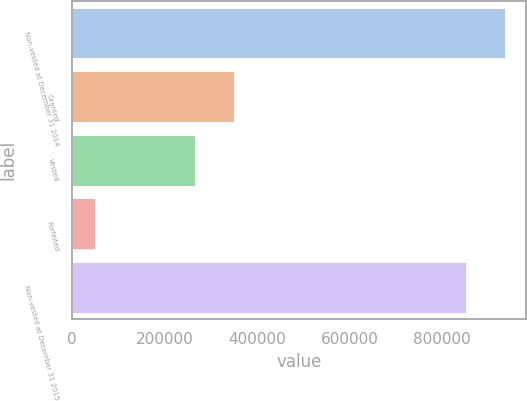Convert chart to OTSL. <chart><loc_0><loc_0><loc_500><loc_500><bar_chart><fcel>Non-vested at December 31 2014<fcel>Granted<fcel>Vested<fcel>Forfeited<fcel>Non-vested at December 31 2015<nl><fcel>936384<fcel>349810<fcel>266683<fcel>49252<fcel>853257<nl></chart> 